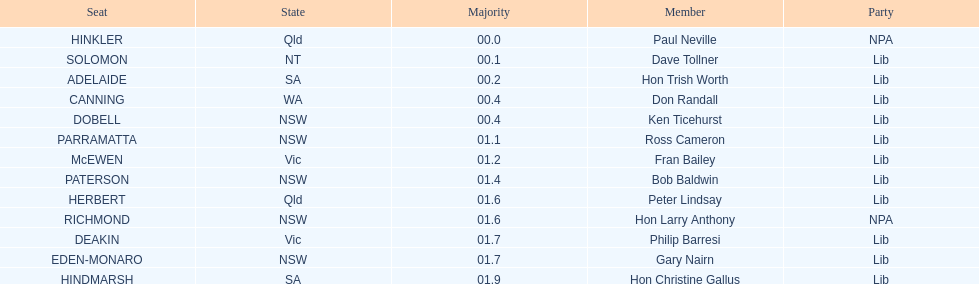What is the name of the last seat? HINDMARSH. 